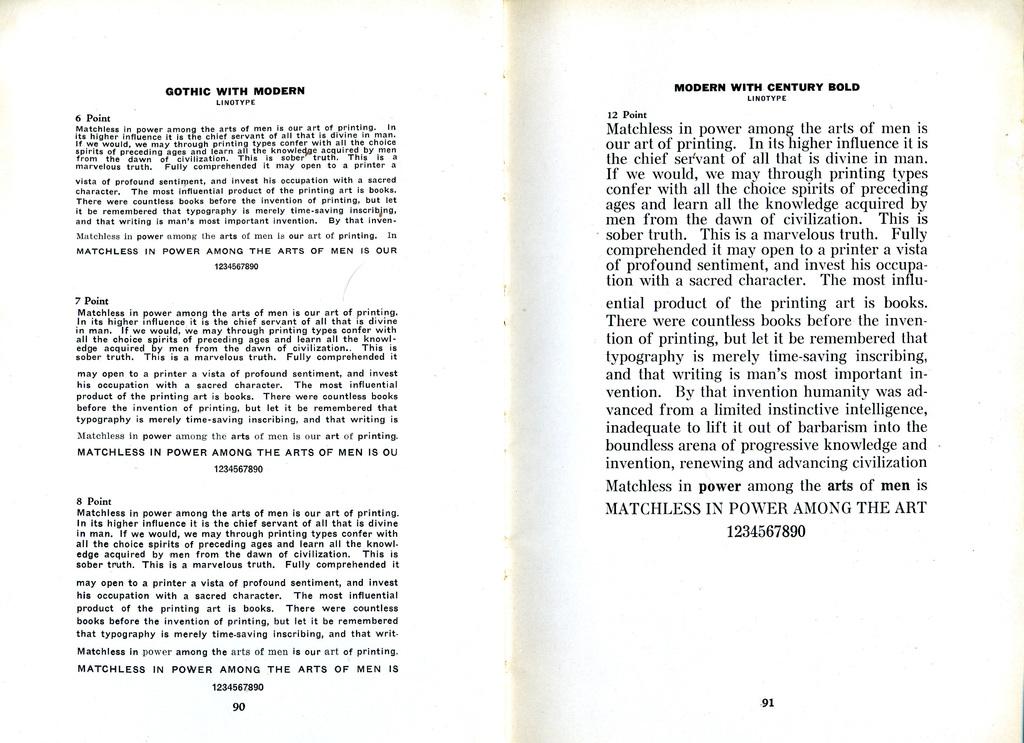What page number?
Ensure brevity in your answer.  Unanswerable. What was the article?
Your answer should be very brief. Gothic with modern. 